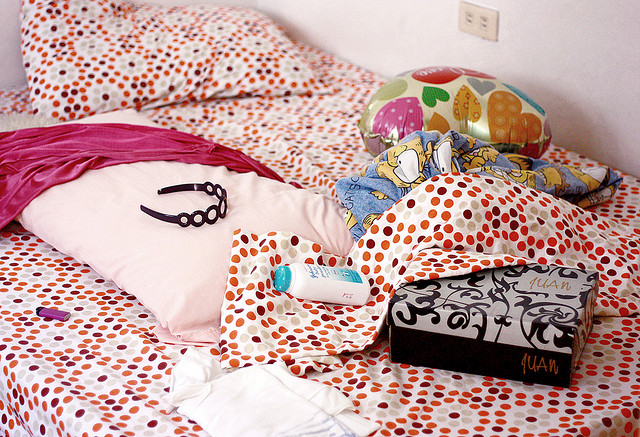Identify the text displayed in this image. 4UAN 4UAN JOHNSON 